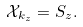Convert formula to latex. <formula><loc_0><loc_0><loc_500><loc_500>\mathcal { X } _ { k _ { z } } = S _ { z } .</formula> 